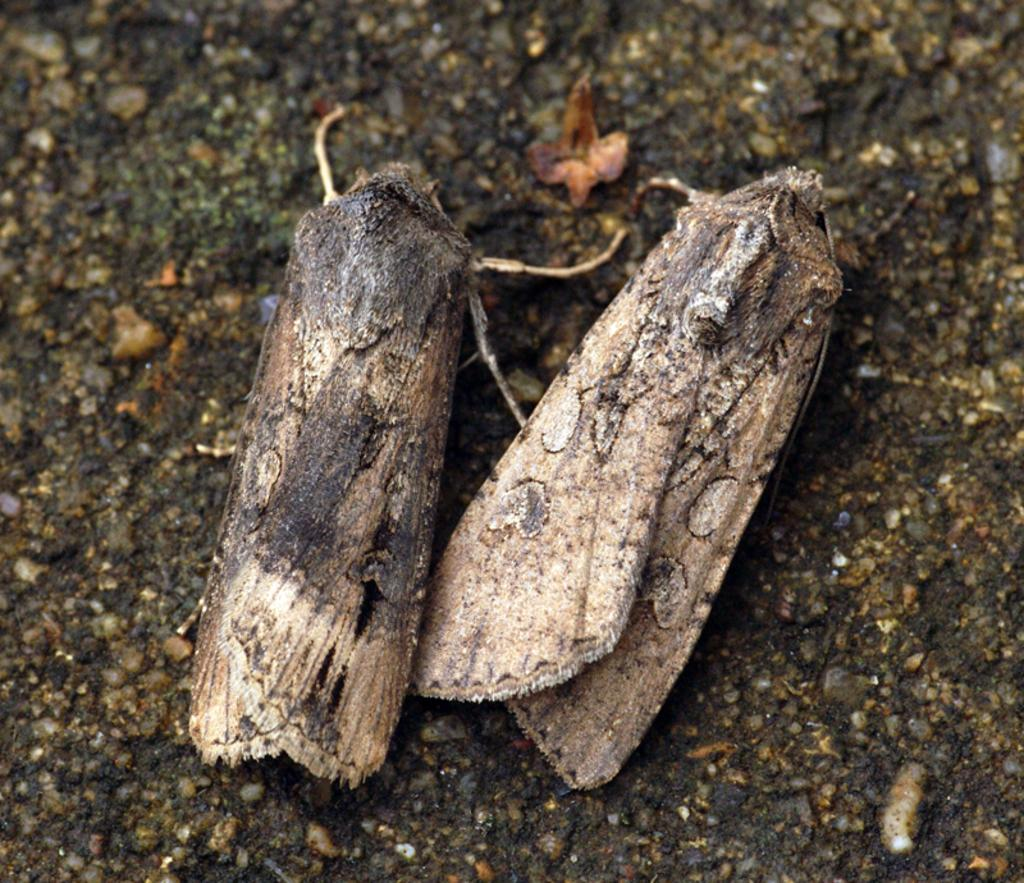How many insects are present in the image? There are two insects in the image. Where are the insects located? The insects are on the land. What type of knot is the dad having trouble with in the image? There is no knot, dad, or trouble present in the image; it only features two insects on the land. 